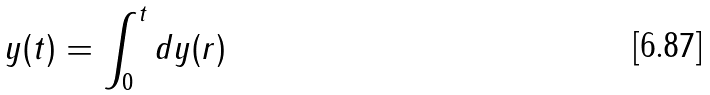<formula> <loc_0><loc_0><loc_500><loc_500>y ( t ) = \int _ { 0 } ^ { t } d y ( r )</formula> 